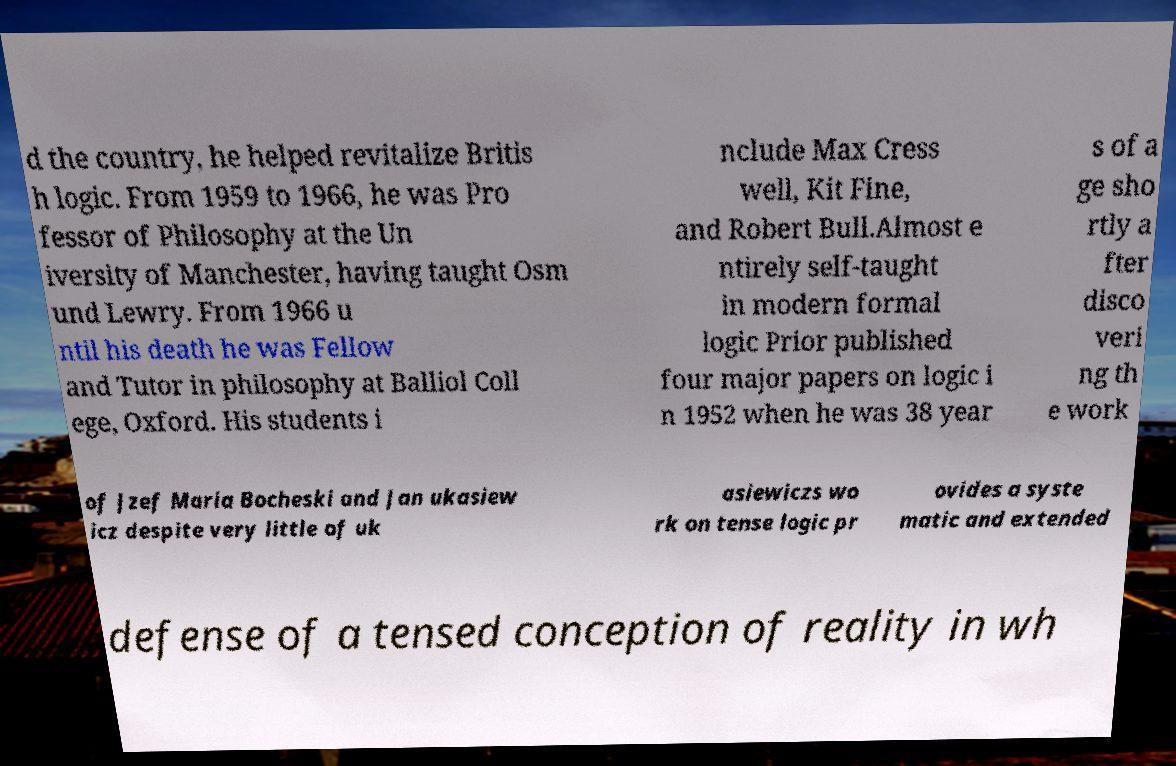Please identify and transcribe the text found in this image. d the country, he helped revitalize Britis h logic. From 1959 to 1966, he was Pro fessor of Philosophy at the Un iversity of Manchester, having taught Osm und Lewry. From 1966 u ntil his death he was Fellow and Tutor in philosophy at Balliol Coll ege, Oxford. His students i nclude Max Cress well, Kit Fine, and Robert Bull.Almost e ntirely self-taught in modern formal logic Prior published four major papers on logic i n 1952 when he was 38 year s of a ge sho rtly a fter disco veri ng th e work of Jzef Maria Bocheski and Jan ukasiew icz despite very little of uk asiewiczs wo rk on tense logic pr ovides a syste matic and extended defense of a tensed conception of reality in wh 